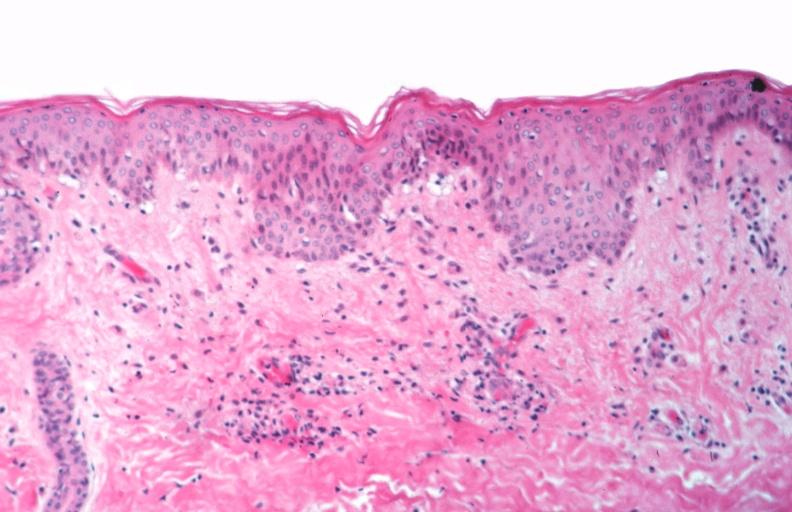s rocky mountain spotted fever, vasculitis?
Answer the question using a single word or phrase. Yes 